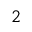<formula> <loc_0><loc_0><loc_500><loc_500>_ { 2 }</formula> 